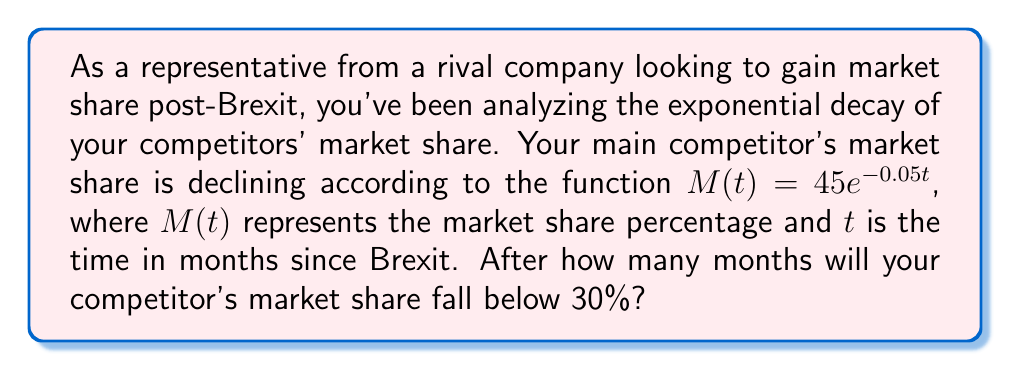What is the answer to this math problem? To solve this problem, we need to use the properties of logarithms and exponential functions. Let's approach this step-by-step:

1) We start with the equation: $M(t) = 45e^{-0.05t}$

2) We want to find when $M(t)$ is less than 30%, so we set up the inequality:
   $45e^{-0.05t} < 30$

3) To solve this, we first divide both sides by 45:
   $e^{-0.05t} < \frac{30}{45} = \frac{2}{3}$

4) Now, we can take the natural logarithm of both sides. Remember, when we take the log of an inequality, the direction of the inequality changes if the log is negative:
   $\ln(e^{-0.05t}) < \ln(\frac{2}{3})$

5) The left side simplifies due to the properties of logarithms:
   $-0.05t < \ln(\frac{2}{3})$

6) Now we can divide both sides by -0.05, remembering to flip the inequality sign:
   $t > -\frac{\ln(\frac{2}{3})}{0.05}$

7) We can calculate this value:
   $t > -\frac{\ln(0.6666...)}{0.05} \approx 8.1093$

8) Since we're looking for the number of months, which must be a whole number, we round up to the next integer.
Answer: The competitor's market share will fall below 30% after 9 months. 